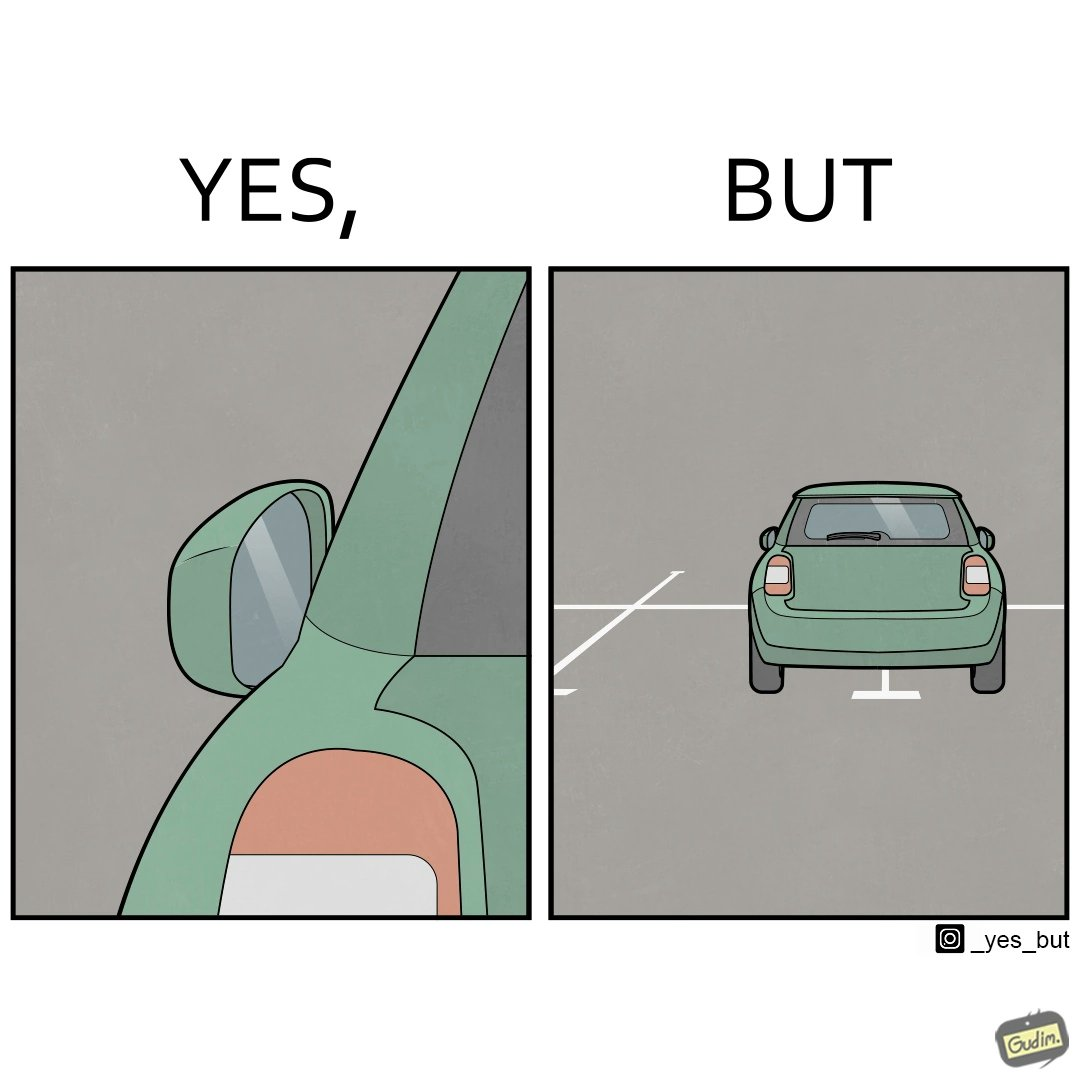Why is this image considered satirical? The image is funny becuase while folding the side mirrors is good when the car is not being used because it prevents damage but it is supposed to be used while driving and parking the car which has not been done in this case leading the car to be parked impropely. 